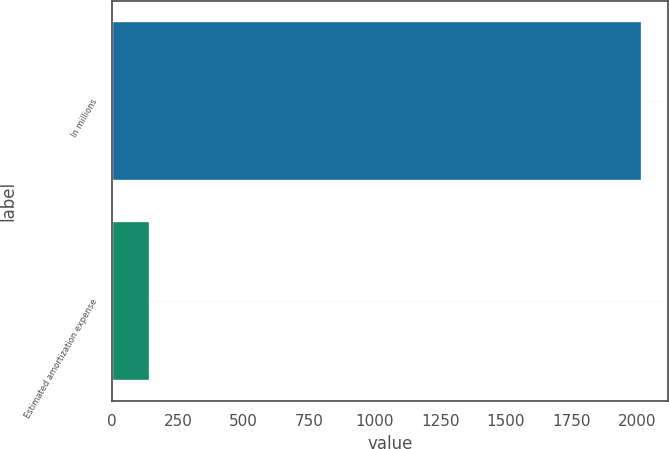Convert chart to OTSL. <chart><loc_0><loc_0><loc_500><loc_500><bar_chart><fcel>In millions<fcel>Estimated amortization expense<nl><fcel>2018<fcel>145.6<nl></chart> 